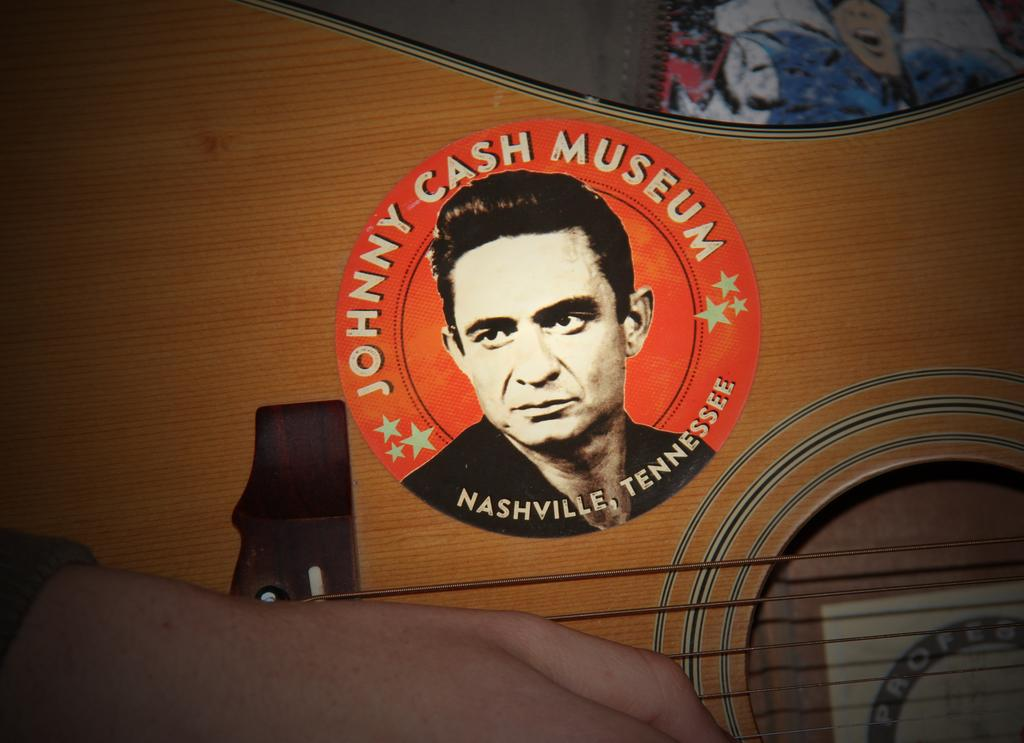What part of a person can be seen in the image? There is a hand of a person in the image. What else is present in the image besides the hand? There is text and images of stars in the image. Can you describe the person depicted on the guitar? There is a person depicted on the guitar, but no specific details about the person are provided. What is the colorful object located in the top right of the image? There is a colorful object in the top right of the image, but its exact nature is not specified. How does the person on the guitar take flight in the image? There is no indication of the person on the guitar taking flight in the image. 